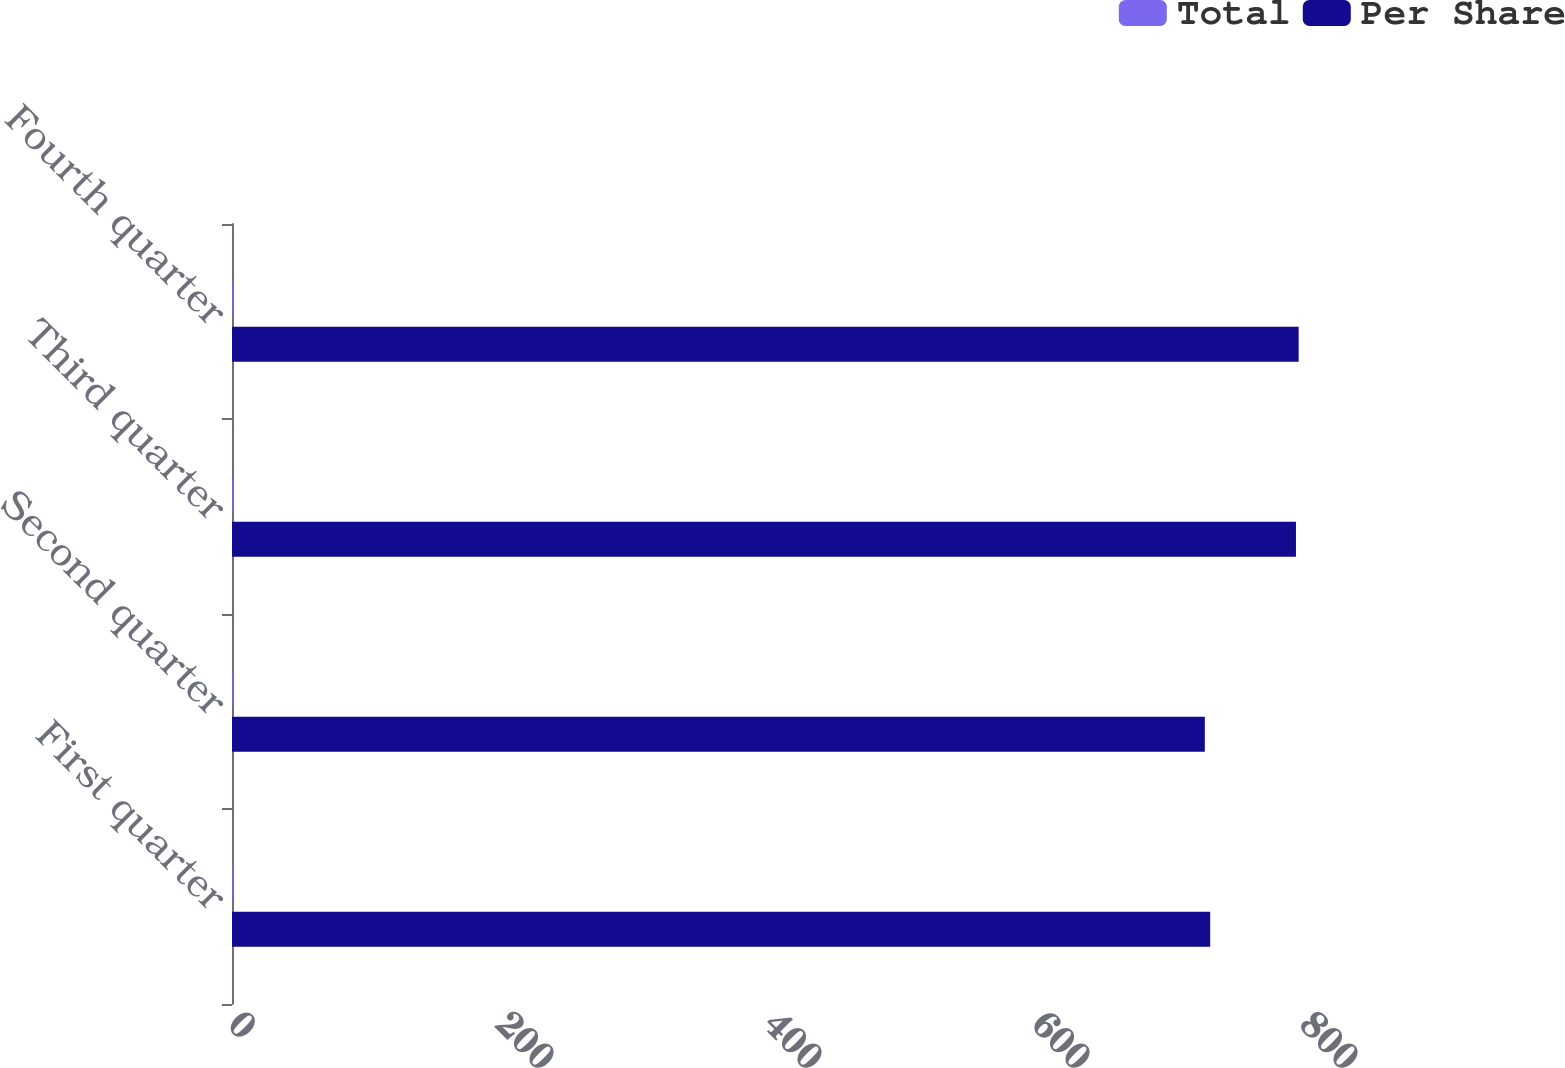Convert chart to OTSL. <chart><loc_0><loc_0><loc_500><loc_500><stacked_bar_chart><ecel><fcel>First quarter<fcel>Second quarter<fcel>Third quarter<fcel>Fourth quarter<nl><fcel>Total<fcel>0.48<fcel>0.48<fcel>0.53<fcel>0.53<nl><fcel>Per Share<fcel>730<fcel>726<fcel>794<fcel>796<nl></chart> 